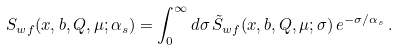Convert formula to latex. <formula><loc_0><loc_0><loc_500><loc_500>S _ { w f } ( x , b , Q , \mu ; \alpha _ { s } ) = \int _ { 0 } ^ { \infty } d \sigma \, \tilde { S } _ { w f } ( x , b , Q , \mu ; \sigma ) \, e ^ { - \sigma / \alpha _ { s } } \, .</formula> 